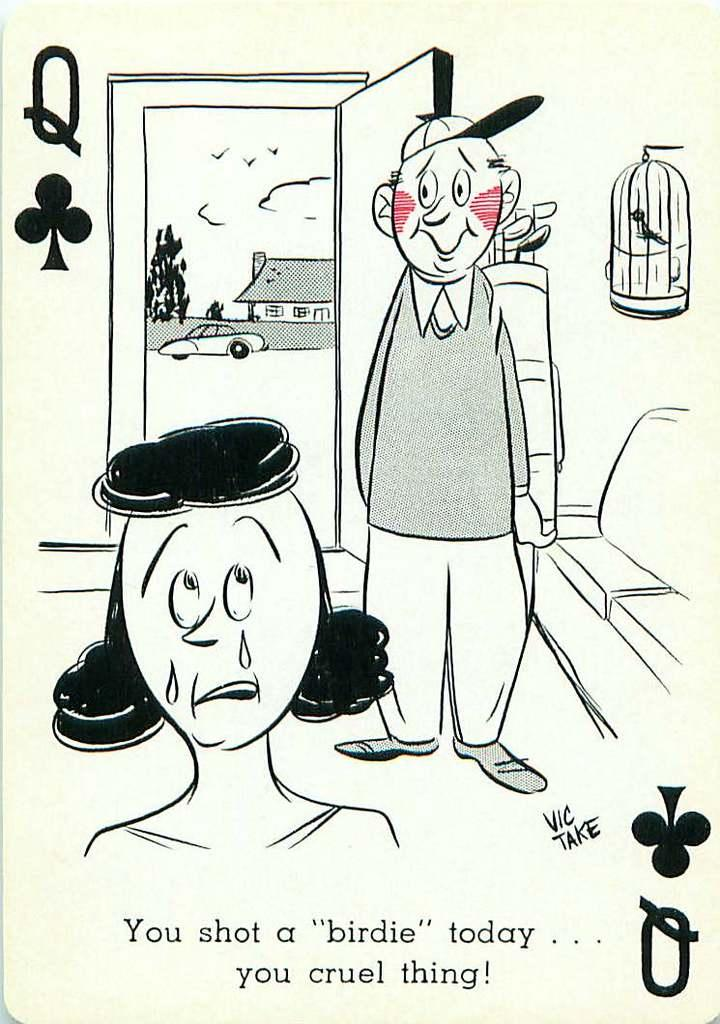How many cartoon persons are in the image? There are two cartoon persons in the image. What is located inside the cage in the image? The facts do not specify what is inside the cage. What type of vehicle is in the image? The facts do not specify the type of vehicle. What structure is visible in the image? There is a house in the image. What type of animals are in the image? There are birds in the image. What organization is responsible for the pain experienced by the cartoon persons in the image? There is no indication of pain or an organization in the image. How does the attention of the birds in the image affect the cartoon persons? There is no indication of the birds' attention affecting the cartoon persons in the image. 